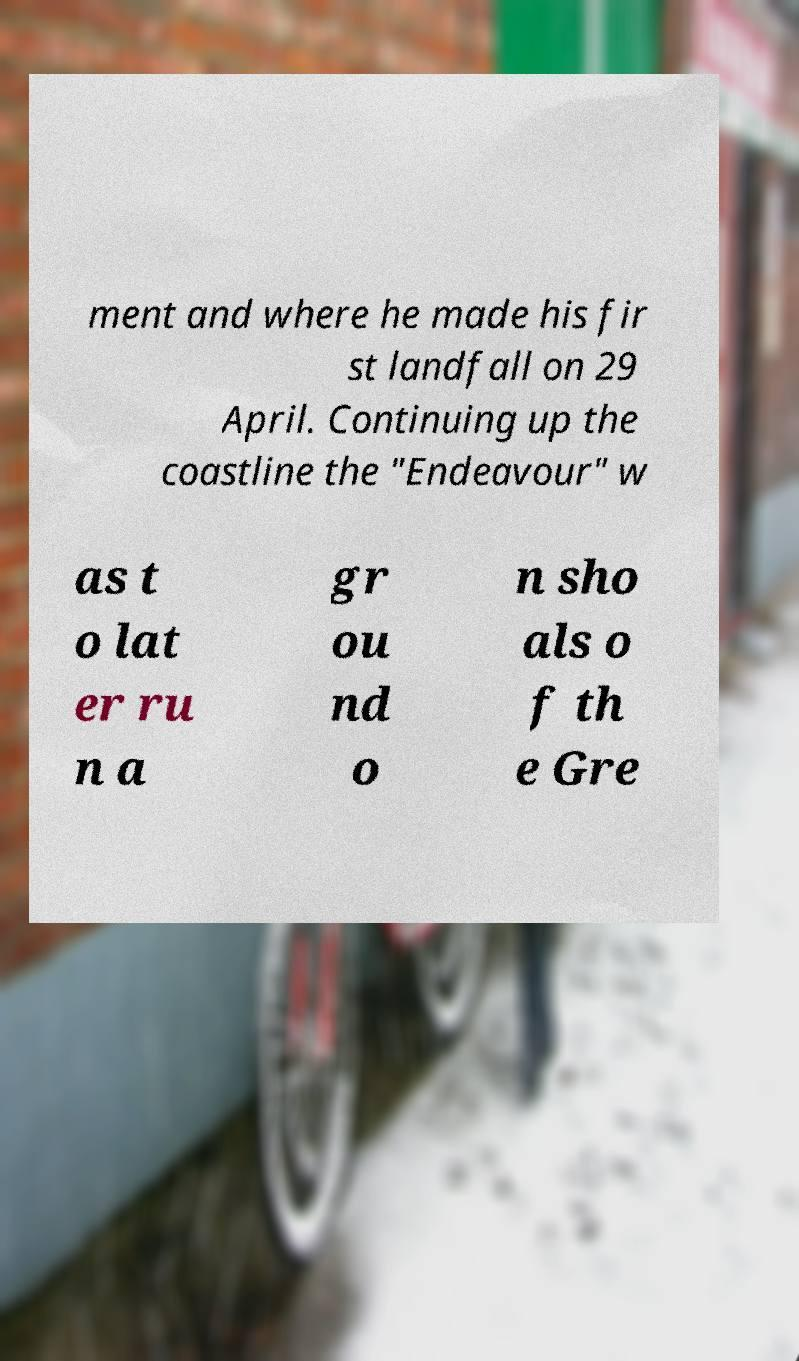There's text embedded in this image that I need extracted. Can you transcribe it verbatim? ment and where he made his fir st landfall on 29 April. Continuing up the coastline the "Endeavour" w as t o lat er ru n a gr ou nd o n sho als o f th e Gre 